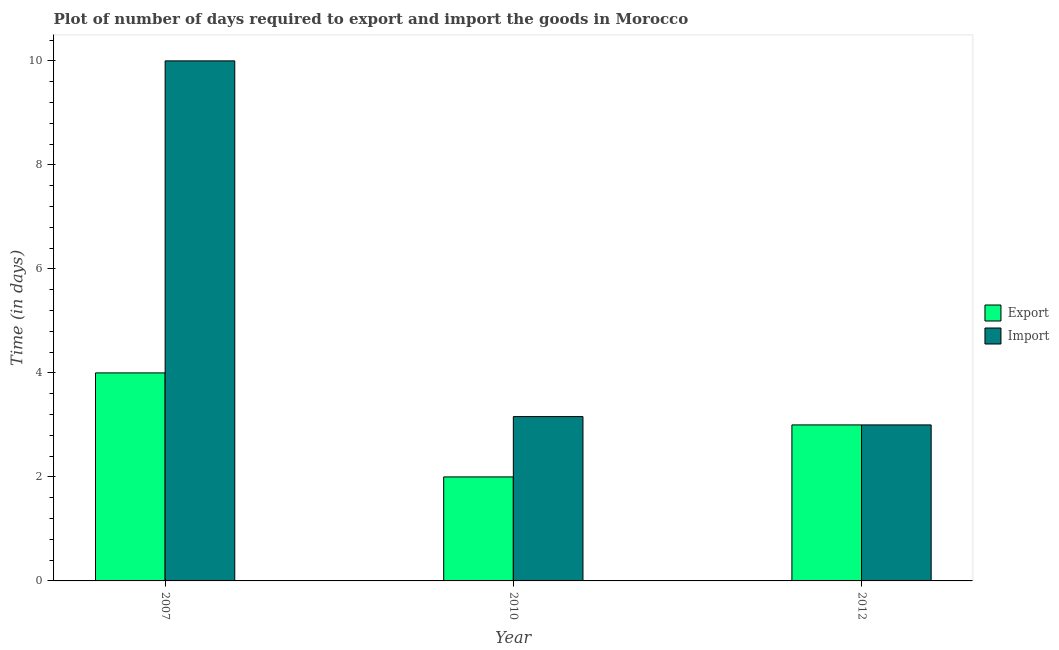Are the number of bars per tick equal to the number of legend labels?
Offer a very short reply. Yes. Are the number of bars on each tick of the X-axis equal?
Your answer should be compact. Yes. How many bars are there on the 1st tick from the left?
Provide a succinct answer. 2. What is the time required to import in 2010?
Make the answer very short. 3.16. Across all years, what is the maximum time required to import?
Your answer should be compact. 10. Across all years, what is the minimum time required to export?
Keep it short and to the point. 2. In which year was the time required to export minimum?
Provide a short and direct response. 2010. What is the total time required to export in the graph?
Keep it short and to the point. 9. What is the difference between the time required to export in 2007 and that in 2012?
Offer a very short reply. 1. What is the difference between the time required to export in 2012 and the time required to import in 2010?
Your answer should be very brief. 1. What is the average time required to import per year?
Provide a short and direct response. 5.39. In the year 2010, what is the difference between the time required to export and time required to import?
Offer a terse response. 0. What is the ratio of the time required to import in 2010 to that in 2012?
Keep it short and to the point. 1.05. Is the time required to import in 2010 less than that in 2012?
Offer a terse response. No. Is the difference between the time required to import in 2007 and 2012 greater than the difference between the time required to export in 2007 and 2012?
Offer a terse response. No. What is the difference between the highest and the second highest time required to import?
Make the answer very short. 6.84. In how many years, is the time required to import greater than the average time required to import taken over all years?
Give a very brief answer. 1. Is the sum of the time required to export in 2010 and 2012 greater than the maximum time required to import across all years?
Offer a terse response. Yes. What does the 2nd bar from the left in 2010 represents?
Make the answer very short. Import. What does the 1st bar from the right in 2010 represents?
Your answer should be very brief. Import. How many bars are there?
Offer a terse response. 6. How many years are there in the graph?
Your answer should be compact. 3. Does the graph contain grids?
Your response must be concise. No. How many legend labels are there?
Offer a very short reply. 2. How are the legend labels stacked?
Make the answer very short. Vertical. What is the title of the graph?
Offer a very short reply. Plot of number of days required to export and import the goods in Morocco. Does "Study and work" appear as one of the legend labels in the graph?
Provide a succinct answer. No. What is the label or title of the X-axis?
Provide a short and direct response. Year. What is the label or title of the Y-axis?
Your answer should be compact. Time (in days). What is the Time (in days) of Import in 2007?
Your response must be concise. 10. What is the Time (in days) of Import in 2010?
Provide a short and direct response. 3.16. Across all years, what is the maximum Time (in days) of Export?
Provide a short and direct response. 4. What is the total Time (in days) of Export in the graph?
Offer a very short reply. 9. What is the total Time (in days) in Import in the graph?
Your answer should be very brief. 16.16. What is the difference between the Time (in days) in Export in 2007 and that in 2010?
Keep it short and to the point. 2. What is the difference between the Time (in days) in Import in 2007 and that in 2010?
Provide a succinct answer. 6.84. What is the difference between the Time (in days) of Import in 2010 and that in 2012?
Ensure brevity in your answer.  0.16. What is the difference between the Time (in days) of Export in 2007 and the Time (in days) of Import in 2010?
Offer a terse response. 0.84. What is the difference between the Time (in days) of Export in 2007 and the Time (in days) of Import in 2012?
Your answer should be very brief. 1. What is the average Time (in days) of Export per year?
Make the answer very short. 3. What is the average Time (in days) in Import per year?
Your response must be concise. 5.39. In the year 2010, what is the difference between the Time (in days) of Export and Time (in days) of Import?
Keep it short and to the point. -1.16. What is the ratio of the Time (in days) in Export in 2007 to that in 2010?
Make the answer very short. 2. What is the ratio of the Time (in days) in Import in 2007 to that in 2010?
Offer a very short reply. 3.16. What is the ratio of the Time (in days) in Export in 2010 to that in 2012?
Give a very brief answer. 0.67. What is the ratio of the Time (in days) of Import in 2010 to that in 2012?
Make the answer very short. 1.05. What is the difference between the highest and the second highest Time (in days) of Export?
Provide a succinct answer. 1. What is the difference between the highest and the second highest Time (in days) of Import?
Give a very brief answer. 6.84. What is the difference between the highest and the lowest Time (in days) in Export?
Offer a terse response. 2. 